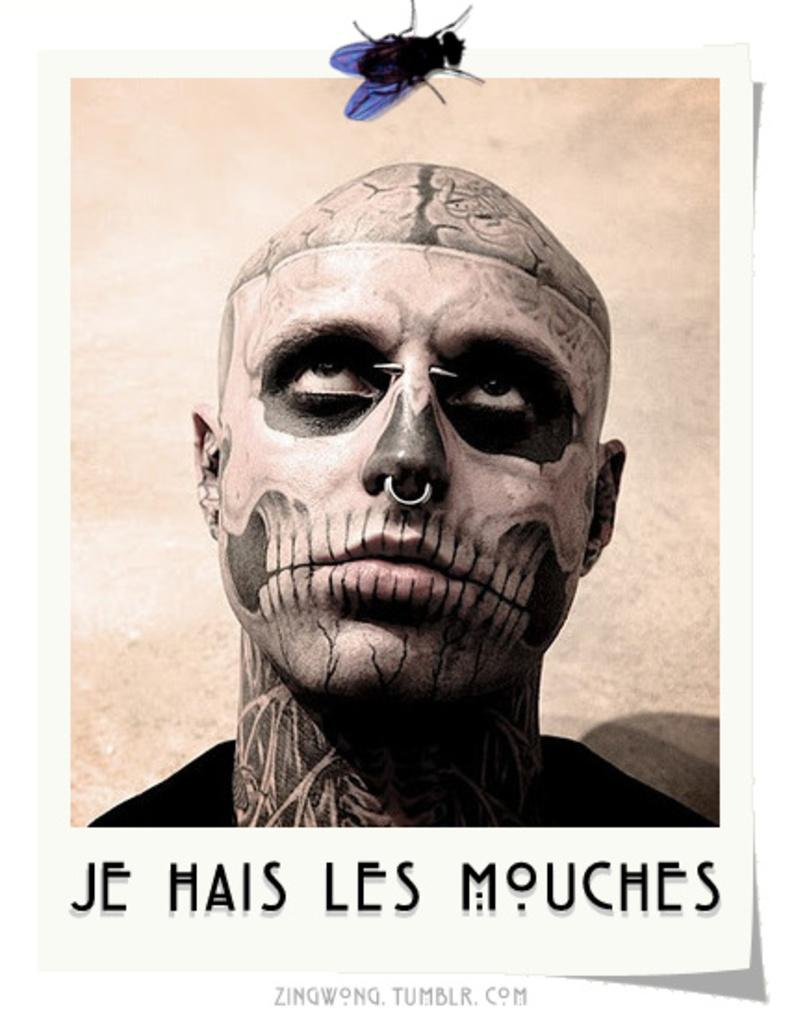How was the image altered or modified? The image is edited. What is featured on the poster in the image? There is a poster in the image that contains a picture of a person. What is written or printed under the picture of the person on the poster? There is text under the picture of the person on the poster. What other image can be seen in the image? There is a picture of a fly above the poster. Is there a ghost visible in the image? No, there is no ghost present in the image. What caption is provided for the picture of the fly? There is no caption for the picture of the fly in the image. 